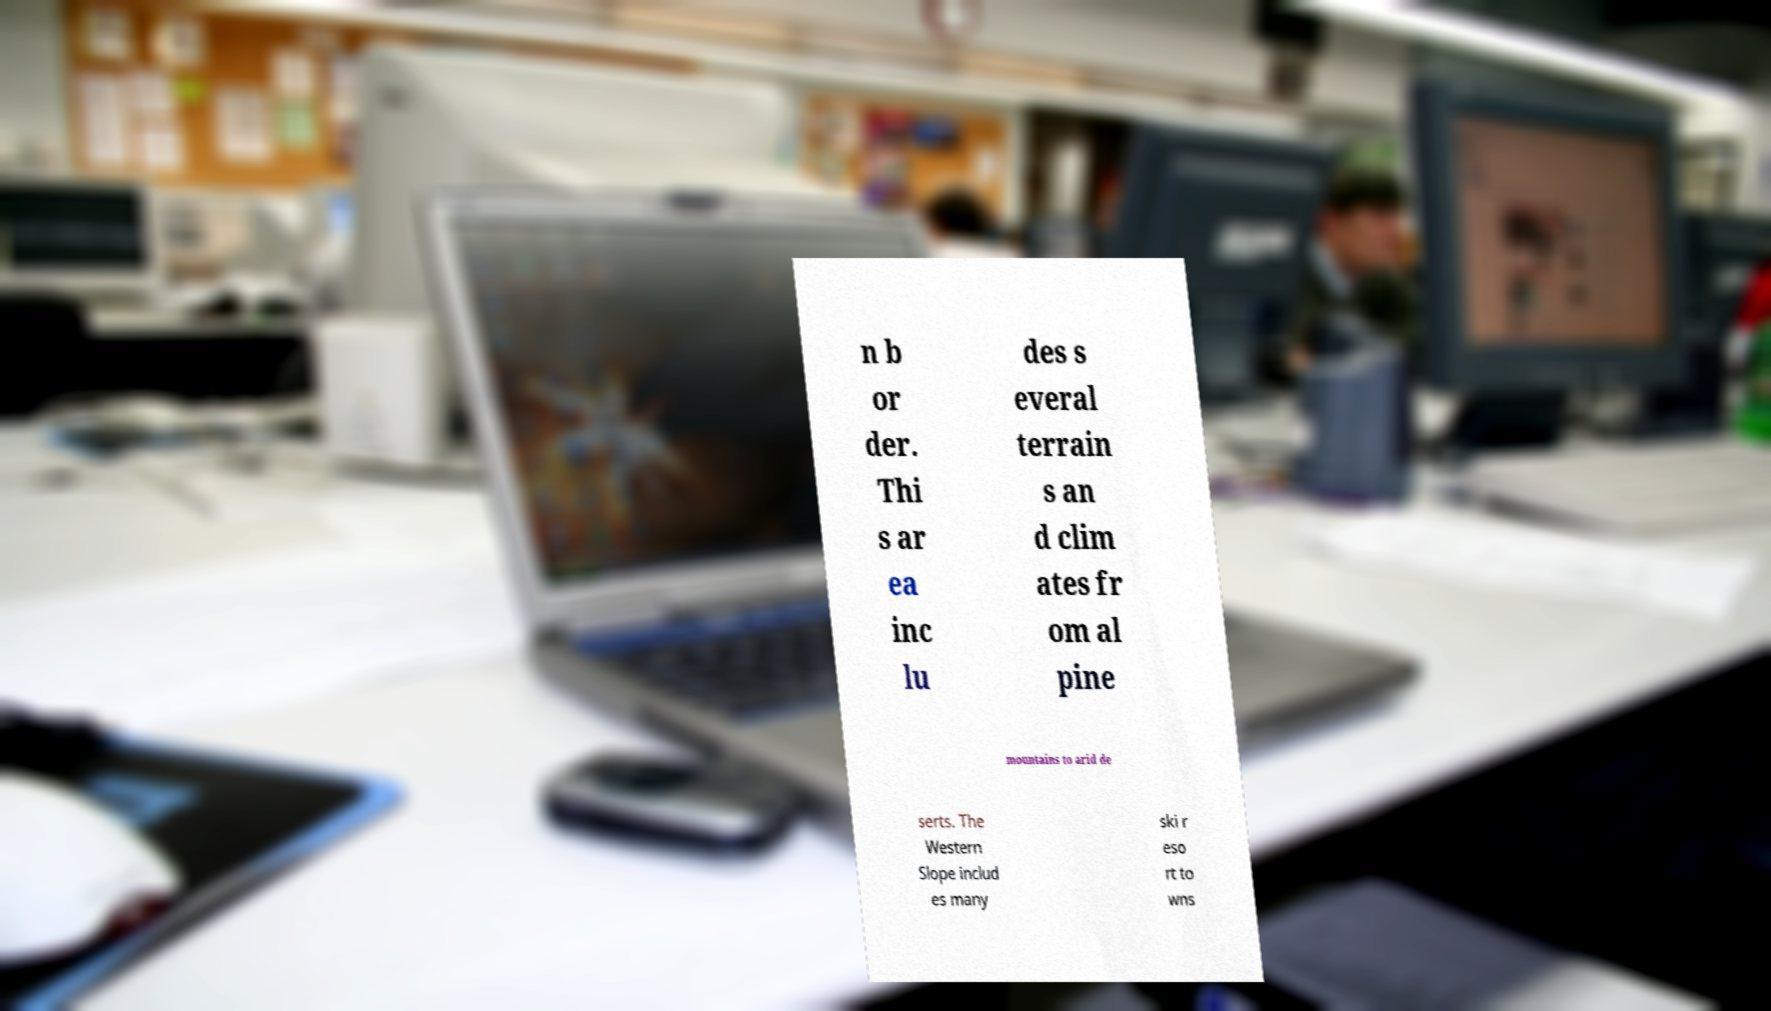For documentation purposes, I need the text within this image transcribed. Could you provide that? n b or der. Thi s ar ea inc lu des s everal terrain s an d clim ates fr om al pine mountains to arid de serts. The Western Slope includ es many ski r eso rt to wns 